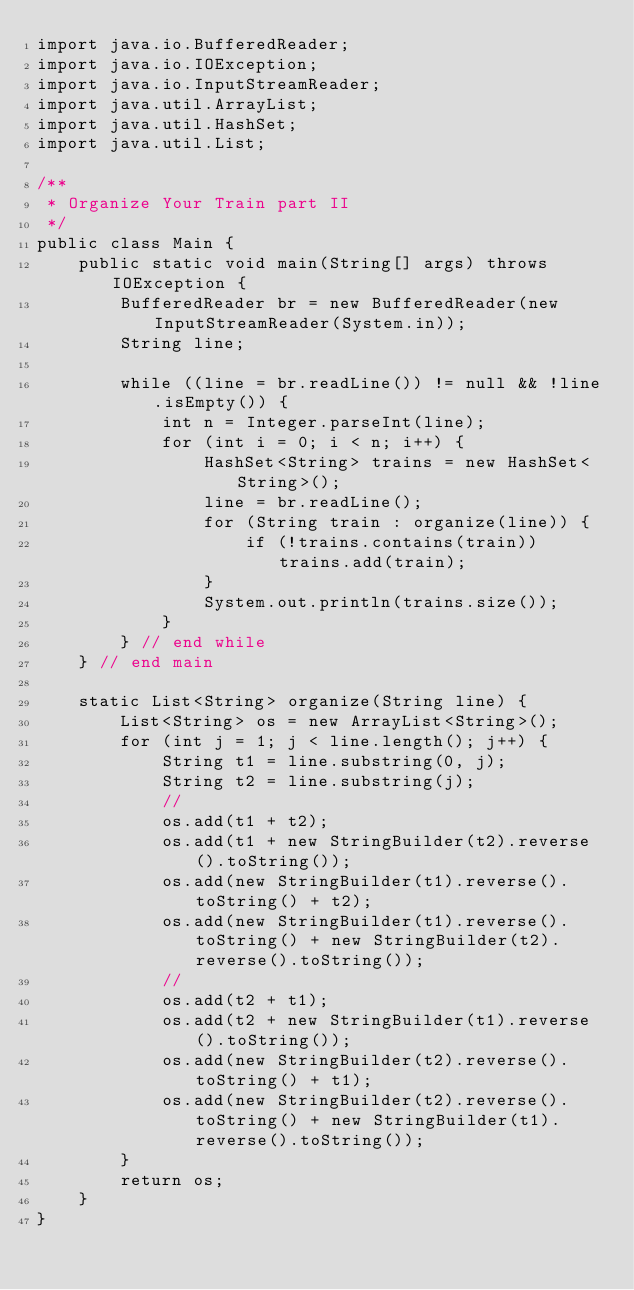Convert code to text. <code><loc_0><loc_0><loc_500><loc_500><_Java_>import java.io.BufferedReader;
import java.io.IOException;
import java.io.InputStreamReader;
import java.util.ArrayList;
import java.util.HashSet;
import java.util.List;

/**
 * Organize Your Train part II
 */
public class Main {
	public static void main(String[] args) throws IOException {
		BufferedReader br = new BufferedReader(new InputStreamReader(System.in));
		String line;

		while ((line = br.readLine()) != null && !line.isEmpty()) {
			int n = Integer.parseInt(line);
			for (int i = 0; i < n; i++) {
				HashSet<String> trains = new HashSet<String>();
				line = br.readLine();
				for (String train : organize(line)) {
					if (!trains.contains(train)) trains.add(train);
				}
				System.out.println(trains.size());
			}
		} // end while
	} // end main

	static List<String> organize(String line) {
		List<String> os = new ArrayList<String>();
		for (int j = 1; j < line.length(); j++) {
			String t1 = line.substring(0, j);
			String t2 = line.substring(j);
			//
			os.add(t1 + t2);
			os.add(t1 + new StringBuilder(t2).reverse().toString());
			os.add(new StringBuilder(t1).reverse().toString() + t2);
			os.add(new StringBuilder(t1).reverse().toString() + new StringBuilder(t2).reverse().toString());
			//
			os.add(t2 + t1);
			os.add(t2 + new StringBuilder(t1).reverse().toString());
			os.add(new StringBuilder(t2).reverse().toString() + t1);
			os.add(new StringBuilder(t2).reverse().toString() + new StringBuilder(t1).reverse().toString());
		}
		return os;
	}
}</code> 